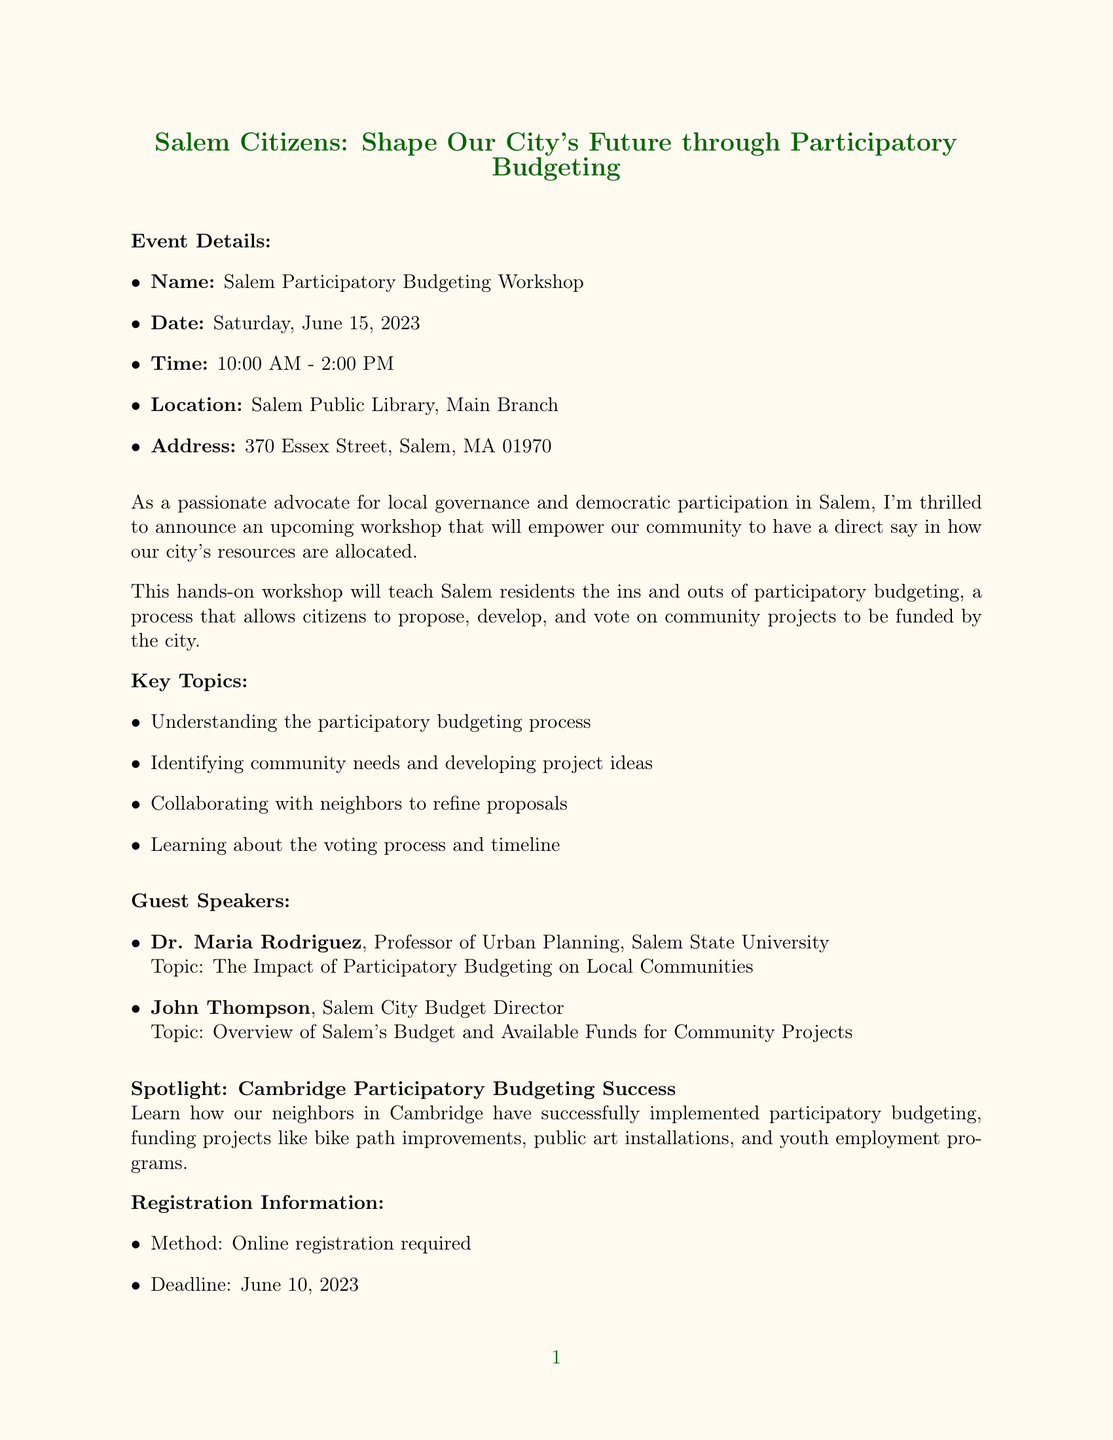what is the name of the workshop? The name of the workshop is explicitly stated in the document.
Answer: Salem Participatory Budgeting Workshop when is the workshop scheduled? The document provides the specific date of the event.
Answer: Saturday, June 15, 2023 where will the workshop take place? The location of the workshop is mentioned in the event details.
Answer: Salem Public Library, Main Branch who is one of the guest speakers? The document lists the guest speakers, so this information can be directly retrieved.
Answer: Dr. Maria Rodriguez what is the registration deadline? The deadline for registration is specified in the registration information section.
Answer: June 10, 2023 what is a key topic covered in the workshop? The document lists several key topics, making it easy to provide examples.
Answer: Understanding the participatory budgeting process how can residents participate in community project proposals? The workshop will teach a specific process for participation mentioned in the description.
Answer: Propose, develop, and vote on community projects what successful project example is mentioned? The document refers to a specific success story to illustrate the concept of participatory budgeting.
Answer: Bike path improvements how is registration conducted for the workshop? The method of registration is clearly outlined in the document.
Answer: Online registration required 